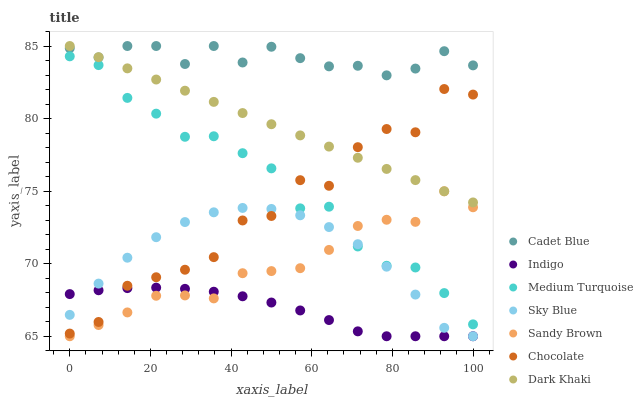Does Indigo have the minimum area under the curve?
Answer yes or no. Yes. Does Cadet Blue have the maximum area under the curve?
Answer yes or no. Yes. Does Chocolate have the minimum area under the curve?
Answer yes or no. No. Does Chocolate have the maximum area under the curve?
Answer yes or no. No. Is Dark Khaki the smoothest?
Answer yes or no. Yes. Is Chocolate the roughest?
Answer yes or no. Yes. Is Indigo the smoothest?
Answer yes or no. No. Is Indigo the roughest?
Answer yes or no. No. Does Indigo have the lowest value?
Answer yes or no. Yes. Does Chocolate have the lowest value?
Answer yes or no. No. Does Dark Khaki have the highest value?
Answer yes or no. Yes. Does Chocolate have the highest value?
Answer yes or no. No. Is Medium Turquoise less than Dark Khaki?
Answer yes or no. Yes. Is Dark Khaki greater than Medium Turquoise?
Answer yes or no. Yes. Does Chocolate intersect Sky Blue?
Answer yes or no. Yes. Is Chocolate less than Sky Blue?
Answer yes or no. No. Is Chocolate greater than Sky Blue?
Answer yes or no. No. Does Medium Turquoise intersect Dark Khaki?
Answer yes or no. No. 